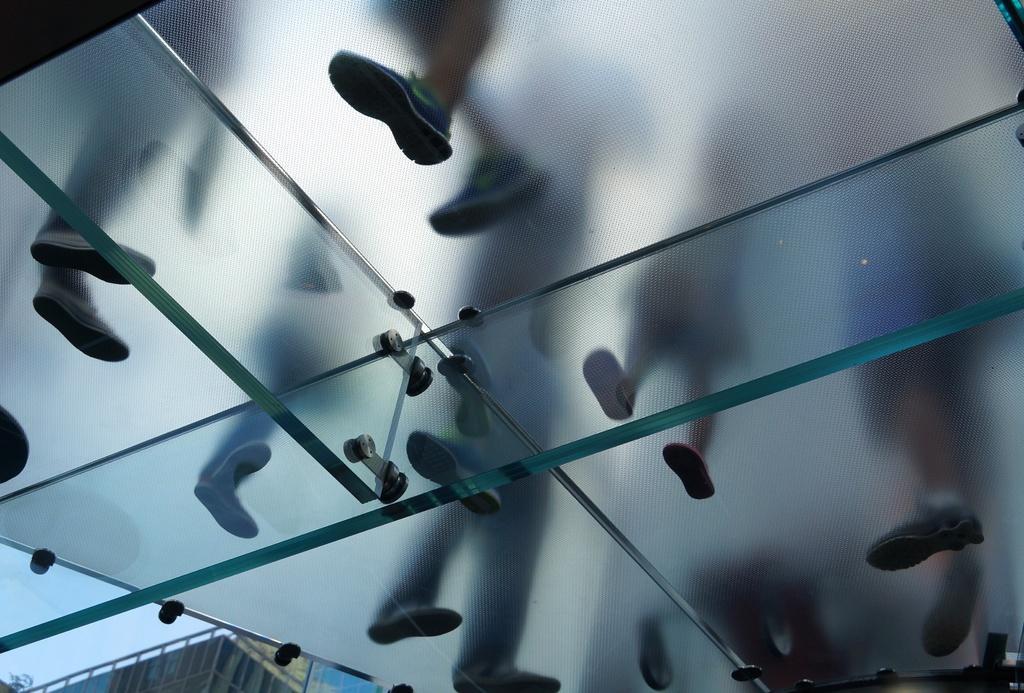In one or two sentences, can you explain what this image depicts? In this image we can see persons feet on the glass. In the background we can see building and sky. 